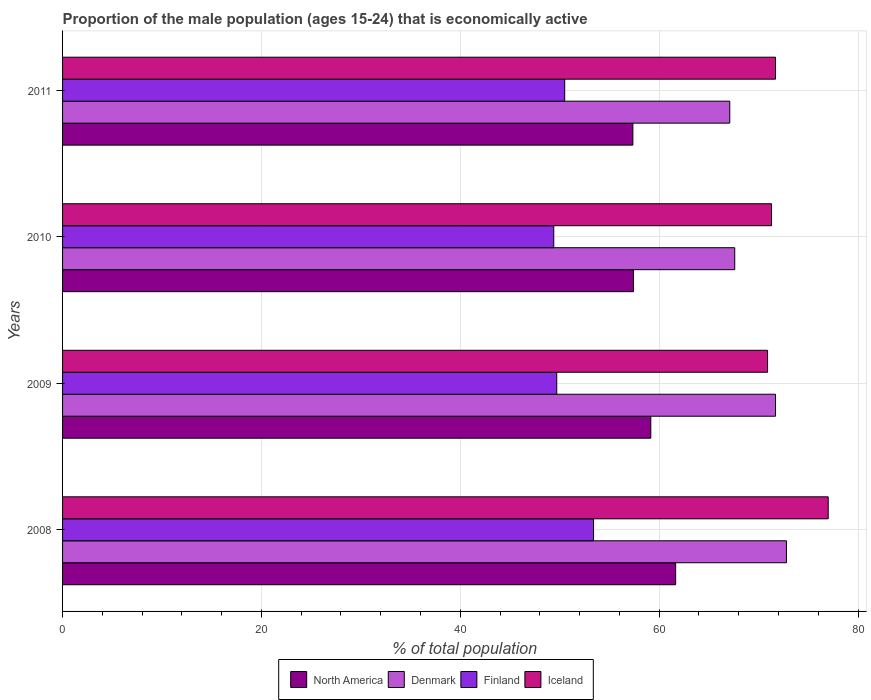How many different coloured bars are there?
Your answer should be compact. 4. Are the number of bars per tick equal to the number of legend labels?
Offer a very short reply. Yes. How many bars are there on the 1st tick from the top?
Provide a succinct answer. 4. What is the label of the 1st group of bars from the top?
Offer a very short reply. 2011. What is the proportion of the male population that is economically active in Finland in 2008?
Your answer should be compact. 53.4. Across all years, what is the maximum proportion of the male population that is economically active in Finland?
Give a very brief answer. 53.4. Across all years, what is the minimum proportion of the male population that is economically active in Finland?
Your answer should be compact. 49.4. In which year was the proportion of the male population that is economically active in Finland maximum?
Offer a terse response. 2008. In which year was the proportion of the male population that is economically active in North America minimum?
Give a very brief answer. 2011. What is the total proportion of the male population that is economically active in North America in the graph?
Your answer should be very brief. 235.58. What is the difference between the proportion of the male population that is economically active in Denmark in 2009 and that in 2010?
Your answer should be compact. 4.1. What is the difference between the proportion of the male population that is economically active in North America in 2009 and the proportion of the male population that is economically active in Iceland in 2011?
Give a very brief answer. -12.54. What is the average proportion of the male population that is economically active in North America per year?
Your response must be concise. 58.9. In the year 2009, what is the difference between the proportion of the male population that is economically active in Finland and proportion of the male population that is economically active in Denmark?
Make the answer very short. -22. In how many years, is the proportion of the male population that is economically active in North America greater than 76 %?
Give a very brief answer. 0. What is the ratio of the proportion of the male population that is economically active in North America in 2010 to that in 2011?
Give a very brief answer. 1. What is the difference between the highest and the second highest proportion of the male population that is economically active in Iceland?
Make the answer very short. 5.3. What is the difference between the highest and the lowest proportion of the male population that is economically active in Denmark?
Offer a very short reply. 5.7. In how many years, is the proportion of the male population that is economically active in North America greater than the average proportion of the male population that is economically active in North America taken over all years?
Offer a terse response. 2. Is the sum of the proportion of the male population that is economically active in North America in 2008 and 2010 greater than the maximum proportion of the male population that is economically active in Finland across all years?
Your response must be concise. Yes. What does the 3rd bar from the top in 2008 represents?
Offer a terse response. Denmark. What does the 3rd bar from the bottom in 2009 represents?
Give a very brief answer. Finland. Are all the bars in the graph horizontal?
Provide a succinct answer. Yes. How many years are there in the graph?
Provide a succinct answer. 4. Are the values on the major ticks of X-axis written in scientific E-notation?
Your answer should be compact. No. Does the graph contain grids?
Provide a short and direct response. Yes. How many legend labels are there?
Offer a very short reply. 4. How are the legend labels stacked?
Your answer should be very brief. Horizontal. What is the title of the graph?
Provide a succinct answer. Proportion of the male population (ages 15-24) that is economically active. What is the label or title of the X-axis?
Give a very brief answer. % of total population. What is the % of total population of North America in 2008?
Offer a terse response. 61.66. What is the % of total population in Denmark in 2008?
Your response must be concise. 72.8. What is the % of total population in Finland in 2008?
Your response must be concise. 53.4. What is the % of total population of North America in 2009?
Provide a short and direct response. 59.16. What is the % of total population in Denmark in 2009?
Your answer should be very brief. 71.7. What is the % of total population of Finland in 2009?
Give a very brief answer. 49.7. What is the % of total population in Iceland in 2009?
Offer a very short reply. 70.9. What is the % of total population in North America in 2010?
Your answer should be very brief. 57.41. What is the % of total population in Denmark in 2010?
Offer a very short reply. 67.6. What is the % of total population in Finland in 2010?
Ensure brevity in your answer.  49.4. What is the % of total population in Iceland in 2010?
Your answer should be very brief. 71.3. What is the % of total population in North America in 2011?
Offer a terse response. 57.36. What is the % of total population in Denmark in 2011?
Offer a terse response. 67.1. What is the % of total population of Finland in 2011?
Keep it short and to the point. 50.5. What is the % of total population in Iceland in 2011?
Keep it short and to the point. 71.7. Across all years, what is the maximum % of total population in North America?
Offer a terse response. 61.66. Across all years, what is the maximum % of total population in Denmark?
Provide a succinct answer. 72.8. Across all years, what is the maximum % of total population of Finland?
Ensure brevity in your answer.  53.4. Across all years, what is the maximum % of total population of Iceland?
Your answer should be very brief. 77. Across all years, what is the minimum % of total population of North America?
Provide a succinct answer. 57.36. Across all years, what is the minimum % of total population in Denmark?
Your response must be concise. 67.1. Across all years, what is the minimum % of total population of Finland?
Ensure brevity in your answer.  49.4. Across all years, what is the minimum % of total population in Iceland?
Your response must be concise. 70.9. What is the total % of total population in North America in the graph?
Keep it short and to the point. 235.58. What is the total % of total population in Denmark in the graph?
Your answer should be compact. 279.2. What is the total % of total population of Finland in the graph?
Your answer should be very brief. 203. What is the total % of total population of Iceland in the graph?
Your answer should be compact. 290.9. What is the difference between the % of total population in North America in 2008 and that in 2009?
Make the answer very short. 2.5. What is the difference between the % of total population of Finland in 2008 and that in 2009?
Provide a short and direct response. 3.7. What is the difference between the % of total population of North America in 2008 and that in 2010?
Offer a very short reply. 4.24. What is the difference between the % of total population in Denmark in 2008 and that in 2010?
Your answer should be compact. 5.2. What is the difference between the % of total population of Finland in 2008 and that in 2010?
Keep it short and to the point. 4. What is the difference between the % of total population in North America in 2008 and that in 2011?
Offer a very short reply. 4.3. What is the difference between the % of total population in Denmark in 2008 and that in 2011?
Give a very brief answer. 5.7. What is the difference between the % of total population of North America in 2009 and that in 2010?
Your answer should be very brief. 1.74. What is the difference between the % of total population of Finland in 2009 and that in 2010?
Your answer should be very brief. 0.3. What is the difference between the % of total population in Iceland in 2009 and that in 2010?
Your answer should be very brief. -0.4. What is the difference between the % of total population in North America in 2009 and that in 2011?
Give a very brief answer. 1.8. What is the difference between the % of total population in Finland in 2009 and that in 2011?
Keep it short and to the point. -0.8. What is the difference between the % of total population of North America in 2010 and that in 2011?
Your answer should be very brief. 0.06. What is the difference between the % of total population of North America in 2008 and the % of total population of Denmark in 2009?
Your answer should be compact. -10.04. What is the difference between the % of total population of North America in 2008 and the % of total population of Finland in 2009?
Ensure brevity in your answer.  11.96. What is the difference between the % of total population of North America in 2008 and the % of total population of Iceland in 2009?
Ensure brevity in your answer.  -9.24. What is the difference between the % of total population in Denmark in 2008 and the % of total population in Finland in 2009?
Offer a terse response. 23.1. What is the difference between the % of total population in Denmark in 2008 and the % of total population in Iceland in 2009?
Give a very brief answer. 1.9. What is the difference between the % of total population in Finland in 2008 and the % of total population in Iceland in 2009?
Your answer should be compact. -17.5. What is the difference between the % of total population of North America in 2008 and the % of total population of Denmark in 2010?
Your response must be concise. -5.94. What is the difference between the % of total population in North America in 2008 and the % of total population in Finland in 2010?
Keep it short and to the point. 12.26. What is the difference between the % of total population of North America in 2008 and the % of total population of Iceland in 2010?
Provide a succinct answer. -9.64. What is the difference between the % of total population in Denmark in 2008 and the % of total population in Finland in 2010?
Your response must be concise. 23.4. What is the difference between the % of total population of Finland in 2008 and the % of total population of Iceland in 2010?
Give a very brief answer. -17.9. What is the difference between the % of total population in North America in 2008 and the % of total population in Denmark in 2011?
Your answer should be compact. -5.44. What is the difference between the % of total population in North America in 2008 and the % of total population in Finland in 2011?
Keep it short and to the point. 11.16. What is the difference between the % of total population of North America in 2008 and the % of total population of Iceland in 2011?
Your answer should be very brief. -10.04. What is the difference between the % of total population in Denmark in 2008 and the % of total population in Finland in 2011?
Your answer should be compact. 22.3. What is the difference between the % of total population in Denmark in 2008 and the % of total population in Iceland in 2011?
Offer a terse response. 1.1. What is the difference between the % of total population in Finland in 2008 and the % of total population in Iceland in 2011?
Your response must be concise. -18.3. What is the difference between the % of total population in North America in 2009 and the % of total population in Denmark in 2010?
Your response must be concise. -8.44. What is the difference between the % of total population in North America in 2009 and the % of total population in Finland in 2010?
Offer a terse response. 9.76. What is the difference between the % of total population of North America in 2009 and the % of total population of Iceland in 2010?
Ensure brevity in your answer.  -12.14. What is the difference between the % of total population in Denmark in 2009 and the % of total population in Finland in 2010?
Your answer should be very brief. 22.3. What is the difference between the % of total population of Finland in 2009 and the % of total population of Iceland in 2010?
Provide a short and direct response. -21.6. What is the difference between the % of total population of North America in 2009 and the % of total population of Denmark in 2011?
Offer a very short reply. -7.94. What is the difference between the % of total population in North America in 2009 and the % of total population in Finland in 2011?
Keep it short and to the point. 8.66. What is the difference between the % of total population of North America in 2009 and the % of total population of Iceland in 2011?
Your response must be concise. -12.54. What is the difference between the % of total population of Denmark in 2009 and the % of total population of Finland in 2011?
Give a very brief answer. 21.2. What is the difference between the % of total population in Denmark in 2009 and the % of total population in Iceland in 2011?
Your response must be concise. 0. What is the difference between the % of total population of Finland in 2009 and the % of total population of Iceland in 2011?
Your response must be concise. -22. What is the difference between the % of total population in North America in 2010 and the % of total population in Denmark in 2011?
Offer a very short reply. -9.69. What is the difference between the % of total population of North America in 2010 and the % of total population of Finland in 2011?
Make the answer very short. 6.91. What is the difference between the % of total population in North America in 2010 and the % of total population in Iceland in 2011?
Ensure brevity in your answer.  -14.29. What is the difference between the % of total population in Denmark in 2010 and the % of total population in Iceland in 2011?
Make the answer very short. -4.1. What is the difference between the % of total population of Finland in 2010 and the % of total population of Iceland in 2011?
Keep it short and to the point. -22.3. What is the average % of total population in North America per year?
Provide a short and direct response. 58.9. What is the average % of total population of Denmark per year?
Make the answer very short. 69.8. What is the average % of total population in Finland per year?
Keep it short and to the point. 50.75. What is the average % of total population in Iceland per year?
Offer a terse response. 72.72. In the year 2008, what is the difference between the % of total population in North America and % of total population in Denmark?
Offer a terse response. -11.14. In the year 2008, what is the difference between the % of total population of North America and % of total population of Finland?
Provide a short and direct response. 8.26. In the year 2008, what is the difference between the % of total population of North America and % of total population of Iceland?
Offer a terse response. -15.34. In the year 2008, what is the difference between the % of total population in Denmark and % of total population in Finland?
Provide a short and direct response. 19.4. In the year 2008, what is the difference between the % of total population of Finland and % of total population of Iceland?
Give a very brief answer. -23.6. In the year 2009, what is the difference between the % of total population in North America and % of total population in Denmark?
Give a very brief answer. -12.54. In the year 2009, what is the difference between the % of total population in North America and % of total population in Finland?
Provide a short and direct response. 9.46. In the year 2009, what is the difference between the % of total population in North America and % of total population in Iceland?
Your answer should be very brief. -11.74. In the year 2009, what is the difference between the % of total population in Denmark and % of total population in Finland?
Provide a short and direct response. 22. In the year 2009, what is the difference between the % of total population of Denmark and % of total population of Iceland?
Offer a very short reply. 0.8. In the year 2009, what is the difference between the % of total population in Finland and % of total population in Iceland?
Your answer should be compact. -21.2. In the year 2010, what is the difference between the % of total population of North America and % of total population of Denmark?
Give a very brief answer. -10.19. In the year 2010, what is the difference between the % of total population in North America and % of total population in Finland?
Ensure brevity in your answer.  8.01. In the year 2010, what is the difference between the % of total population of North America and % of total population of Iceland?
Keep it short and to the point. -13.89. In the year 2010, what is the difference between the % of total population in Denmark and % of total population in Finland?
Offer a terse response. 18.2. In the year 2010, what is the difference between the % of total population of Denmark and % of total population of Iceland?
Make the answer very short. -3.7. In the year 2010, what is the difference between the % of total population of Finland and % of total population of Iceland?
Provide a short and direct response. -21.9. In the year 2011, what is the difference between the % of total population in North America and % of total population in Denmark?
Provide a short and direct response. -9.74. In the year 2011, what is the difference between the % of total population in North America and % of total population in Finland?
Keep it short and to the point. 6.86. In the year 2011, what is the difference between the % of total population in North America and % of total population in Iceland?
Your answer should be compact. -14.34. In the year 2011, what is the difference between the % of total population in Denmark and % of total population in Finland?
Make the answer very short. 16.6. In the year 2011, what is the difference between the % of total population of Finland and % of total population of Iceland?
Provide a short and direct response. -21.2. What is the ratio of the % of total population in North America in 2008 to that in 2009?
Make the answer very short. 1.04. What is the ratio of the % of total population of Denmark in 2008 to that in 2009?
Keep it short and to the point. 1.02. What is the ratio of the % of total population of Finland in 2008 to that in 2009?
Ensure brevity in your answer.  1.07. What is the ratio of the % of total population in Iceland in 2008 to that in 2009?
Offer a very short reply. 1.09. What is the ratio of the % of total population in North America in 2008 to that in 2010?
Your answer should be compact. 1.07. What is the ratio of the % of total population of Finland in 2008 to that in 2010?
Provide a succinct answer. 1.08. What is the ratio of the % of total population of Iceland in 2008 to that in 2010?
Make the answer very short. 1.08. What is the ratio of the % of total population of North America in 2008 to that in 2011?
Give a very brief answer. 1.07. What is the ratio of the % of total population in Denmark in 2008 to that in 2011?
Your answer should be compact. 1.08. What is the ratio of the % of total population in Finland in 2008 to that in 2011?
Provide a short and direct response. 1.06. What is the ratio of the % of total population in Iceland in 2008 to that in 2011?
Your response must be concise. 1.07. What is the ratio of the % of total population in North America in 2009 to that in 2010?
Keep it short and to the point. 1.03. What is the ratio of the % of total population of Denmark in 2009 to that in 2010?
Make the answer very short. 1.06. What is the ratio of the % of total population of Finland in 2009 to that in 2010?
Your response must be concise. 1.01. What is the ratio of the % of total population of North America in 2009 to that in 2011?
Offer a very short reply. 1.03. What is the ratio of the % of total population of Denmark in 2009 to that in 2011?
Provide a succinct answer. 1.07. What is the ratio of the % of total population in Finland in 2009 to that in 2011?
Give a very brief answer. 0.98. What is the ratio of the % of total population in Iceland in 2009 to that in 2011?
Your response must be concise. 0.99. What is the ratio of the % of total population in North America in 2010 to that in 2011?
Your response must be concise. 1. What is the ratio of the % of total population in Denmark in 2010 to that in 2011?
Offer a terse response. 1.01. What is the ratio of the % of total population of Finland in 2010 to that in 2011?
Ensure brevity in your answer.  0.98. What is the difference between the highest and the second highest % of total population of North America?
Give a very brief answer. 2.5. What is the difference between the highest and the lowest % of total population of North America?
Offer a terse response. 4.3. What is the difference between the highest and the lowest % of total population of Denmark?
Provide a short and direct response. 5.7. What is the difference between the highest and the lowest % of total population of Finland?
Provide a succinct answer. 4. What is the difference between the highest and the lowest % of total population of Iceland?
Keep it short and to the point. 6.1. 